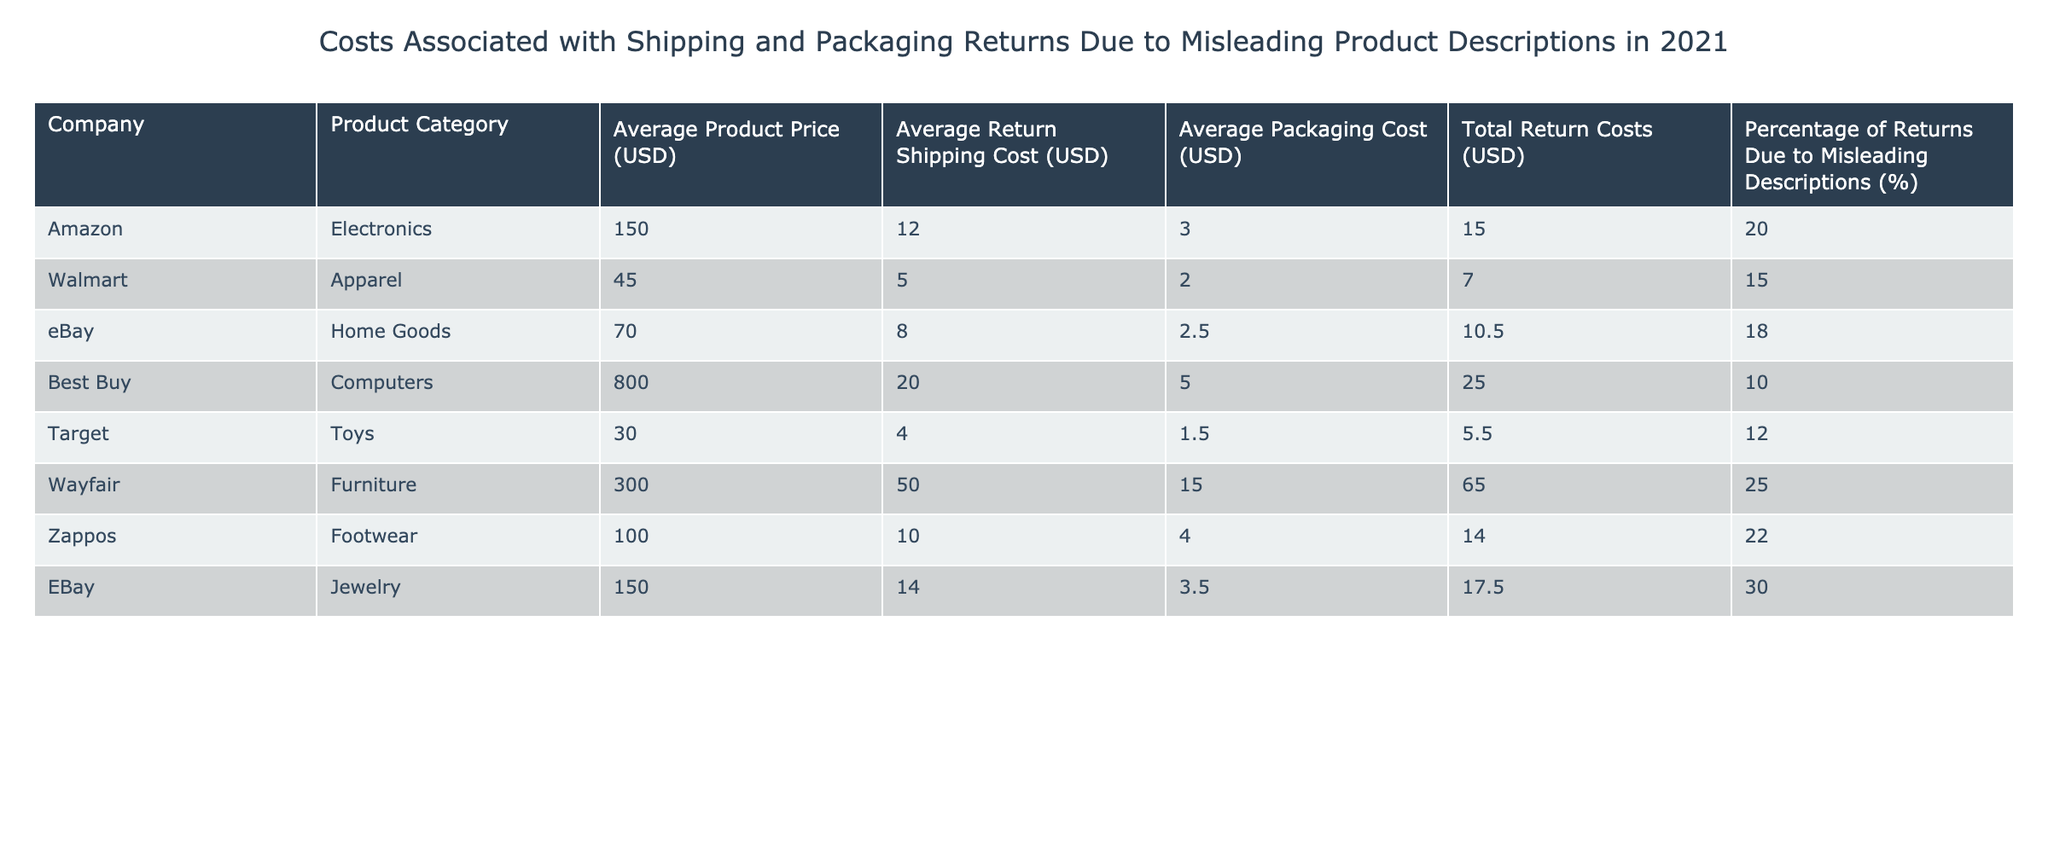What is the average return shipping cost for electronics? The average return shipping cost for electronics is listed directly under the corresponding column for the "Amazon" row, which shows a value of 12.00.
Answer: 12.00 Which company has the highest total return costs? By looking through each company's total return costs, "Wayfair" has the highest value of 65.00.
Answer: Wayfair Is the percentage of returns due to misleading descriptions higher for footwear than for apparel? The percentage of returns due to misleading descriptions for footwear (22%) is higher than for apparel (15%). Therefore, the statement is true.
Answer: Yes What are the average return shipping costs for all companies combined? To find the average return shipping cost, add all the return shipping costs (12 + 5 + 8 + 20 + 4 + 50 + 10 + 14 = 123) and divide by the number of companies (8). This results in an average return shipping cost of 123 / 8 = 15.375.
Answer: 15.38 Which product category has the lowest total return costs and what is that amount? Checking the total return costs for each product category, the "Target" row shows the lowest total return costs of 5.50.
Answer: 5.50 Does eBay have a higher average product price than Amazon? On comparing the average product price, eBay's average product price (70.00 for Home Goods) is lower than Amazon's average product price (150.00 for Electronics). Therefore, the statement is false.
Answer: No What is the difference in average product price between the most expensive and least expensive product categories? The most expensive category is "Best Buy" with an average product price of 800.00, while the least expensive is "Target" with 30.00. The difference is 800.00 - 30.00 = 770.00.
Answer: 770.00 Which company has the lowest percentage of returns due to misleading descriptions? Reviewing the percentages, "Best Buy" has the lowest percentage of 10% compared to the other companies.
Answer: Best Buy Is the average packaging cost for "eBay" more than for "Zappos"? eBay's average packaging cost is 3.50, while Zappos' average packaging cost is 4.00. Since 3.50 is less than 4.00, the statement is false.
Answer: No 